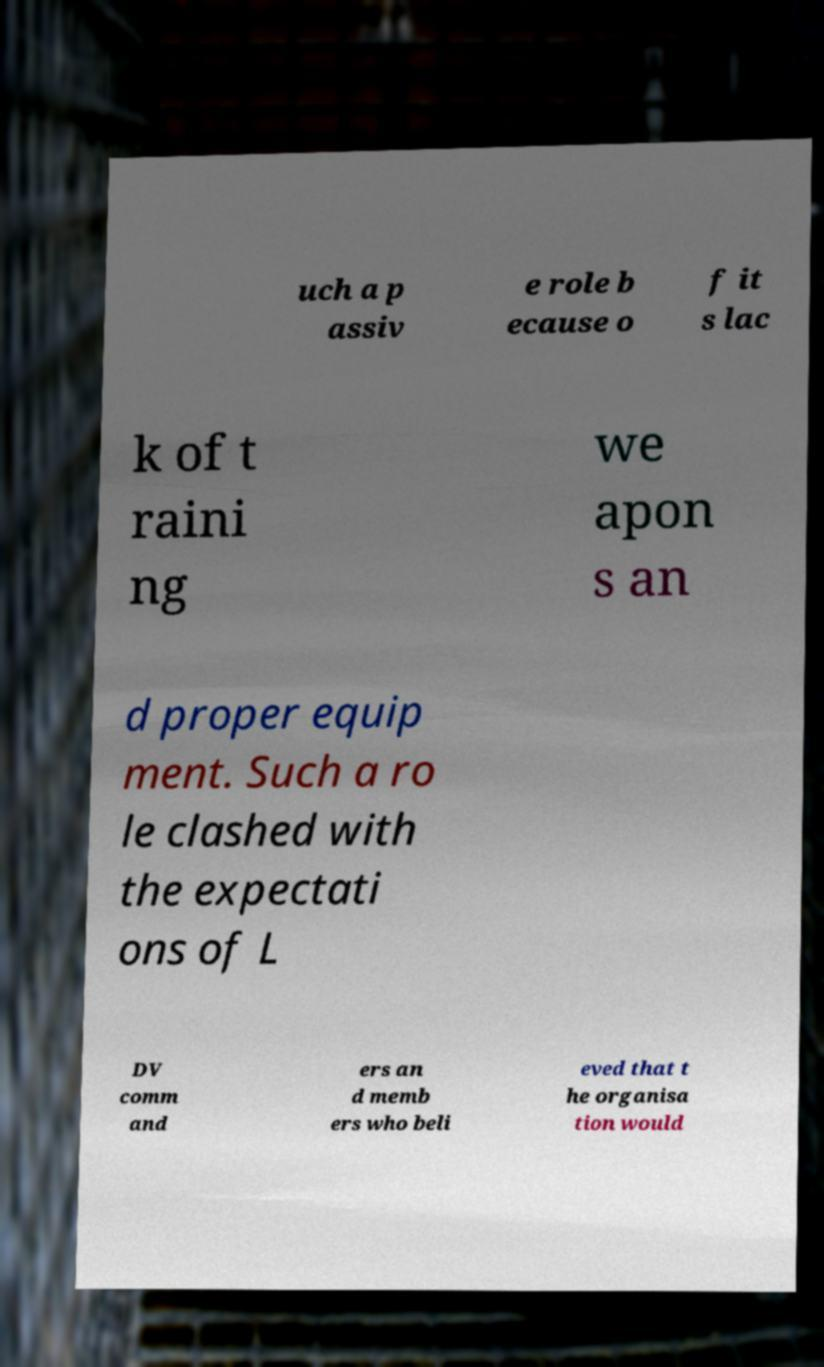There's text embedded in this image that I need extracted. Can you transcribe it verbatim? uch a p assiv e role b ecause o f it s lac k of t raini ng we apon s an d proper equip ment. Such a ro le clashed with the expectati ons of L DV comm and ers an d memb ers who beli eved that t he organisa tion would 